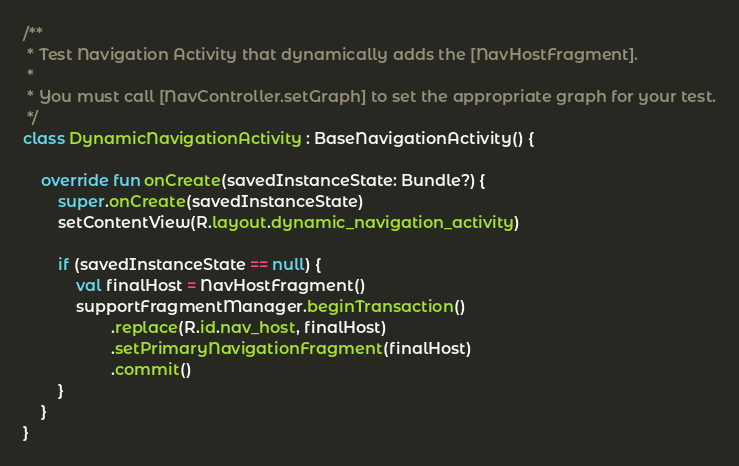Convert code to text. <code><loc_0><loc_0><loc_500><loc_500><_Kotlin_>
/**
 * Test Navigation Activity that dynamically adds the [NavHostFragment].
 *
 * You must call [NavController.setGraph] to set the appropriate graph for your test.
 */
class DynamicNavigationActivity : BaseNavigationActivity() {

    override fun onCreate(savedInstanceState: Bundle?) {
        super.onCreate(savedInstanceState)
        setContentView(R.layout.dynamic_navigation_activity)

        if (savedInstanceState == null) {
            val finalHost = NavHostFragment()
            supportFragmentManager.beginTransaction()
                    .replace(R.id.nav_host, finalHost)
                    .setPrimaryNavigationFragment(finalHost)
                    .commit()
        }
    }
}
</code> 